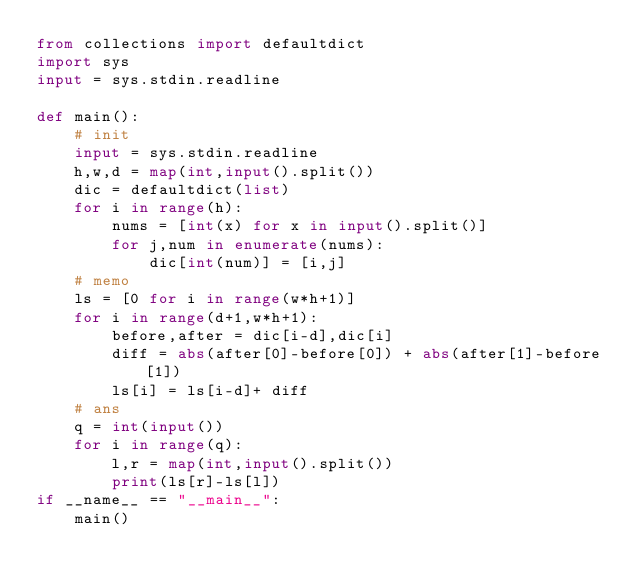<code> <loc_0><loc_0><loc_500><loc_500><_Python_>from collections import defaultdict
import sys
input = sys.stdin.readline

def main():
    # init
    input = sys.stdin.readline
    h,w,d = map(int,input().split())
    dic = defaultdict(list)
    for i in range(h):
        nums = [int(x) for x in input().split()]
        for j,num in enumerate(nums):
            dic[int(num)] = [i,j]
    # memo
    ls = [0 for i in range(w*h+1)]
    for i in range(d+1,w*h+1):
        before,after = dic[i-d],dic[i]
        diff = abs(after[0]-before[0]) + abs(after[1]-before[1])
        ls[i] = ls[i-d]+ diff
    # ans
    q = int(input())
    for i in range(q):
        l,r = map(int,input().split())
        print(ls[r]-ls[l])
if __name__ == "__main__":
    main()</code> 